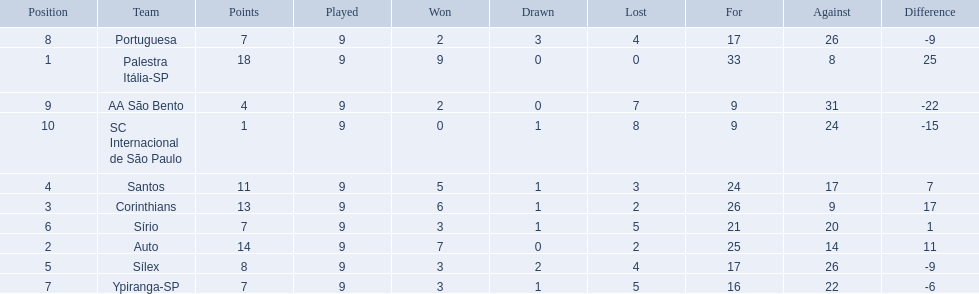What are all the teams? Palestra Itália-SP, Auto, Corinthians, Santos, Sílex, Sírio, Ypiranga-SP, Portuguesa, AA São Bento, SC Internacional de São Paulo. How many times did each team lose? 0, 2, 2, 3, 4, 5, 5, 4, 7, 8. And which team never lost? Palestra Itália-SP. What were the top three amounts of games won for 1926 in brazilian football season? 9, 7, 6. What were the top amount of games won for 1926 in brazilian football season? 9. What team won the top amount of games Palestra Itália-SP. 